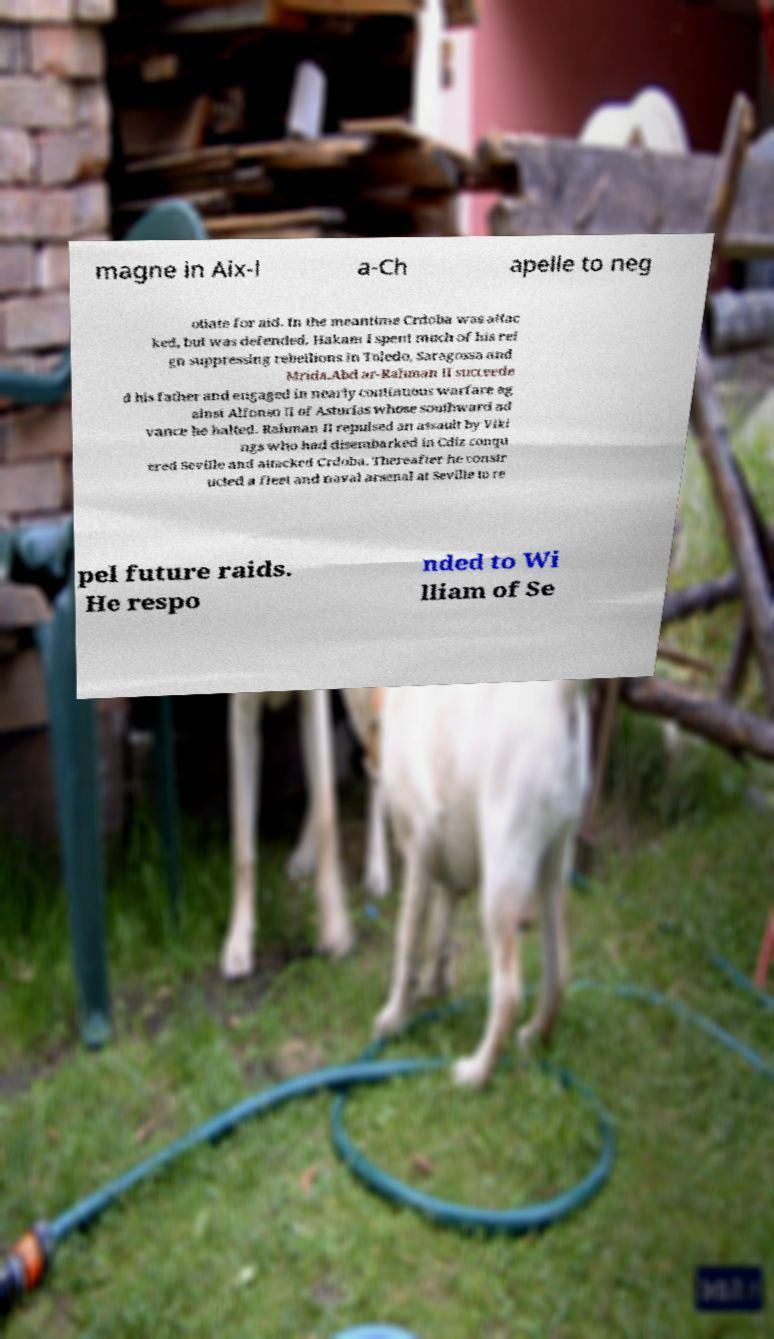Could you assist in decoding the text presented in this image and type it out clearly? magne in Aix-l a-Ch apelle to neg otiate for aid. In the meantime Crdoba was attac ked, but was defended. Hakam I spent much of his rei gn suppressing rebellions in Toledo, Saragossa and Mrida.Abd ar-Rahman II succeede d his father and engaged in nearly continuous warfare ag ainst Alfonso II of Asturias whose southward ad vance he halted. Rahman II repulsed an assault by Viki ngs who had disembarked in Cdiz conqu ered Seville and attacked Crdoba. Thereafter he constr ucted a fleet and naval arsenal at Seville to re pel future raids. He respo nded to Wi lliam of Se 